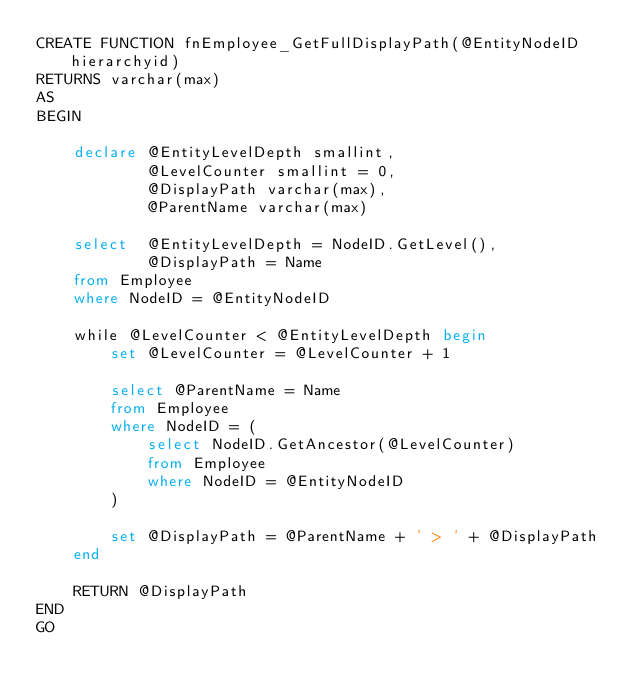<code> <loc_0><loc_0><loc_500><loc_500><_SQL_>CREATE FUNCTION fnEmployee_GetFullDisplayPath(@EntityNodeID hierarchyid)
RETURNS varchar(max)
AS
BEGIN

	declare @EntityLevelDepth smallint,
			@LevelCounter smallint = 0,
			@DisplayPath varchar(max),
			@ParentName varchar(max)

	select	@EntityLevelDepth = NodeID.GetLevel(),
			@DisplayPath = Name
	from Employee 
	where NodeID = @EntityNodeID

	while @LevelCounter < @EntityLevelDepth begin
		set @LevelCounter = @LevelCounter + 1

		select @ParentName = Name
		from Employee
		where NodeID = (
			select NodeID.GetAncestor(@LevelCounter)
			from Employee
			where NodeID = @EntityNodeID
		)

		set @DisplayPath = @ParentName + ' > ' + @DisplayPath
	end

	RETURN @DisplayPath
END
GO
</code> 